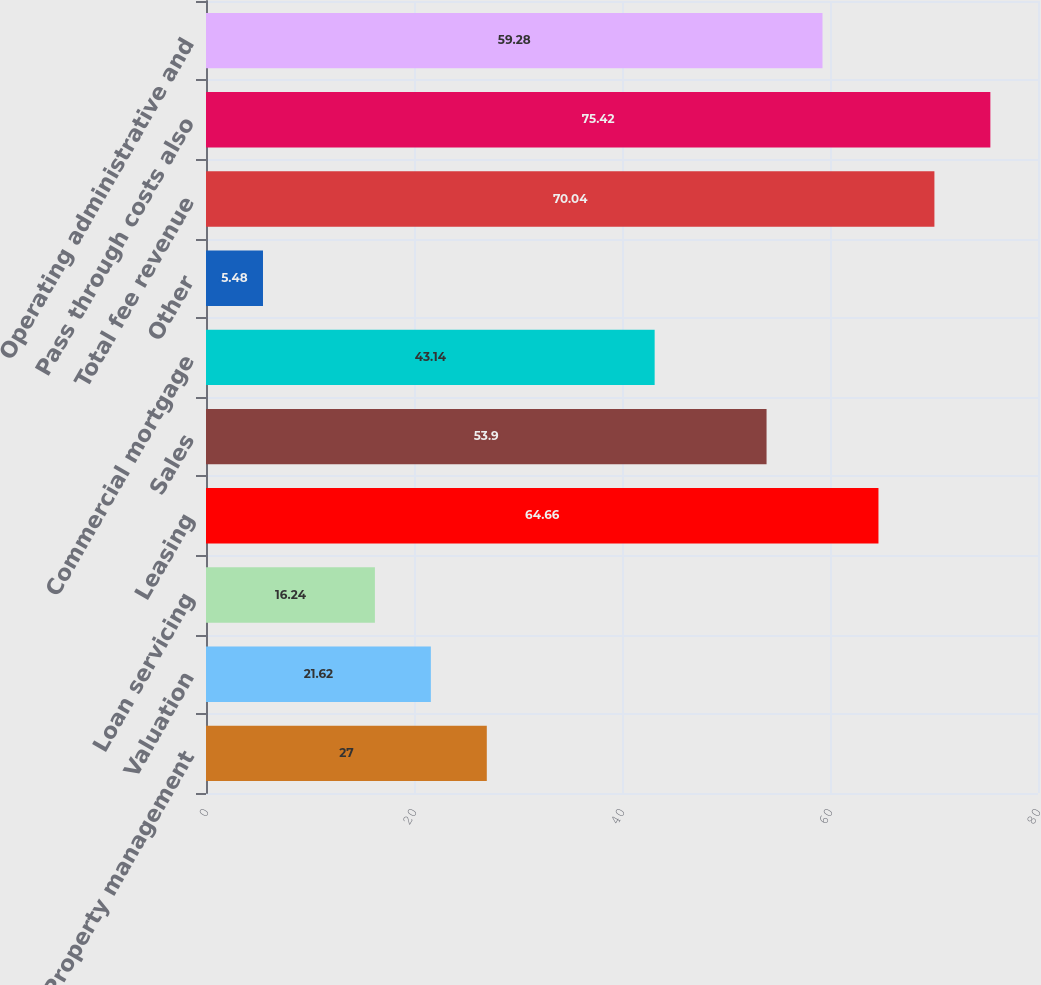<chart> <loc_0><loc_0><loc_500><loc_500><bar_chart><fcel>Property management<fcel>Valuation<fcel>Loan servicing<fcel>Leasing<fcel>Sales<fcel>Commercial mortgage<fcel>Other<fcel>Total fee revenue<fcel>Pass through costs also<fcel>Operating administrative and<nl><fcel>27<fcel>21.62<fcel>16.24<fcel>64.66<fcel>53.9<fcel>43.14<fcel>5.48<fcel>70.04<fcel>75.42<fcel>59.28<nl></chart> 